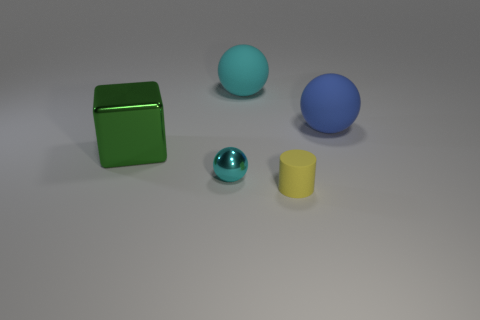Is the material of the cyan ball in front of the big green block the same as the yellow thing?
Offer a terse response. No. The sphere that is both behind the tiny metal sphere and left of the rubber cylinder is made of what material?
Your answer should be compact. Rubber. There is a matte object in front of the big object left of the small cyan metal sphere; what is its color?
Ensure brevity in your answer.  Yellow. What material is the other cyan thing that is the same shape as the small shiny thing?
Give a very brief answer. Rubber. What color is the large matte ball on the right side of the cyan ball right of the metal object in front of the large block?
Offer a terse response. Blue. How many objects are either big gray rubber balls or cyan things?
Your response must be concise. 2. How many big metal objects are the same shape as the large blue matte object?
Offer a terse response. 0. Is the material of the large cyan ball the same as the small thing behind the cylinder?
Offer a terse response. No. There is a blue thing that is the same material as the yellow object; what size is it?
Give a very brief answer. Large. What size is the thing that is behind the blue matte sphere?
Your answer should be very brief. Large. 